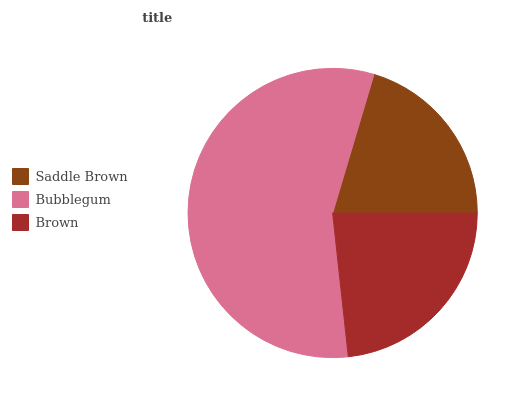Is Saddle Brown the minimum?
Answer yes or no. Yes. Is Bubblegum the maximum?
Answer yes or no. Yes. Is Brown the minimum?
Answer yes or no. No. Is Brown the maximum?
Answer yes or no. No. Is Bubblegum greater than Brown?
Answer yes or no. Yes. Is Brown less than Bubblegum?
Answer yes or no. Yes. Is Brown greater than Bubblegum?
Answer yes or no. No. Is Bubblegum less than Brown?
Answer yes or no. No. Is Brown the high median?
Answer yes or no. Yes. Is Brown the low median?
Answer yes or no. Yes. Is Bubblegum the high median?
Answer yes or no. No. Is Bubblegum the low median?
Answer yes or no. No. 